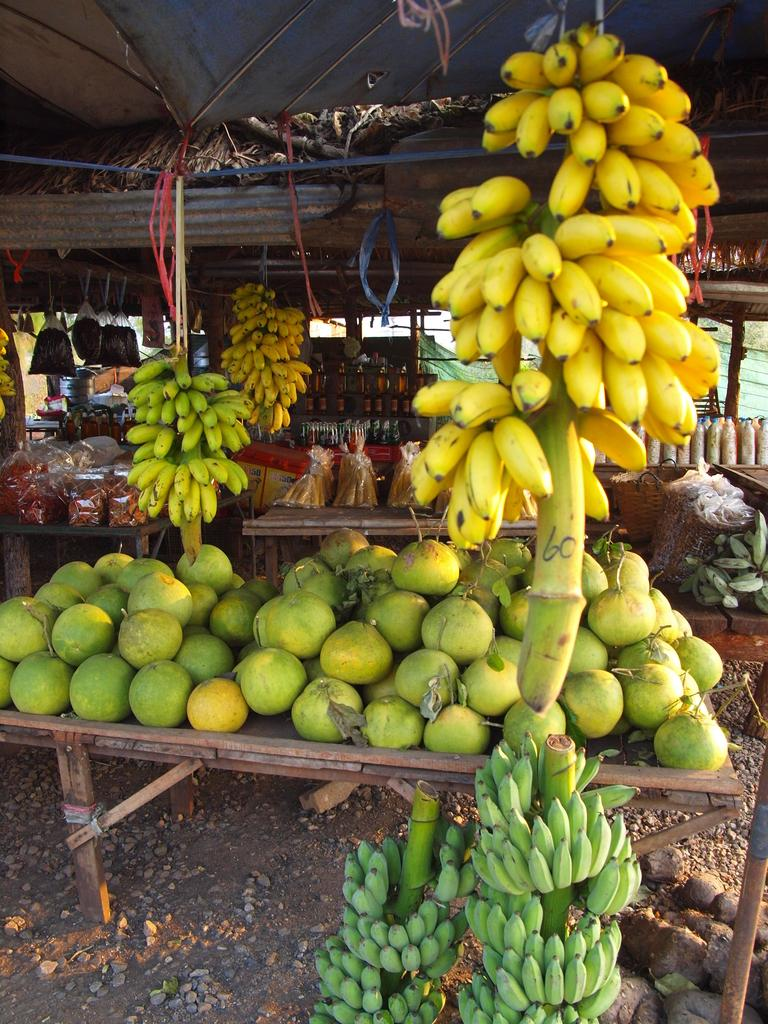What type of food can be seen in the image? There are fruits in the image. What colors are the fruits? The fruits have green and yellow colors. Where are some of the fruits located? Some fruits are on a table. What else can be found in the shed besides the fruits? There are additional items packed in the shed. What type of cake is being prepared in the image? There is no cake being prepared in the image; it features fruits. What is the limit of the fruits in the image? There is no limit mentioned for the fruits in the image; they are simply depicted as they are. 